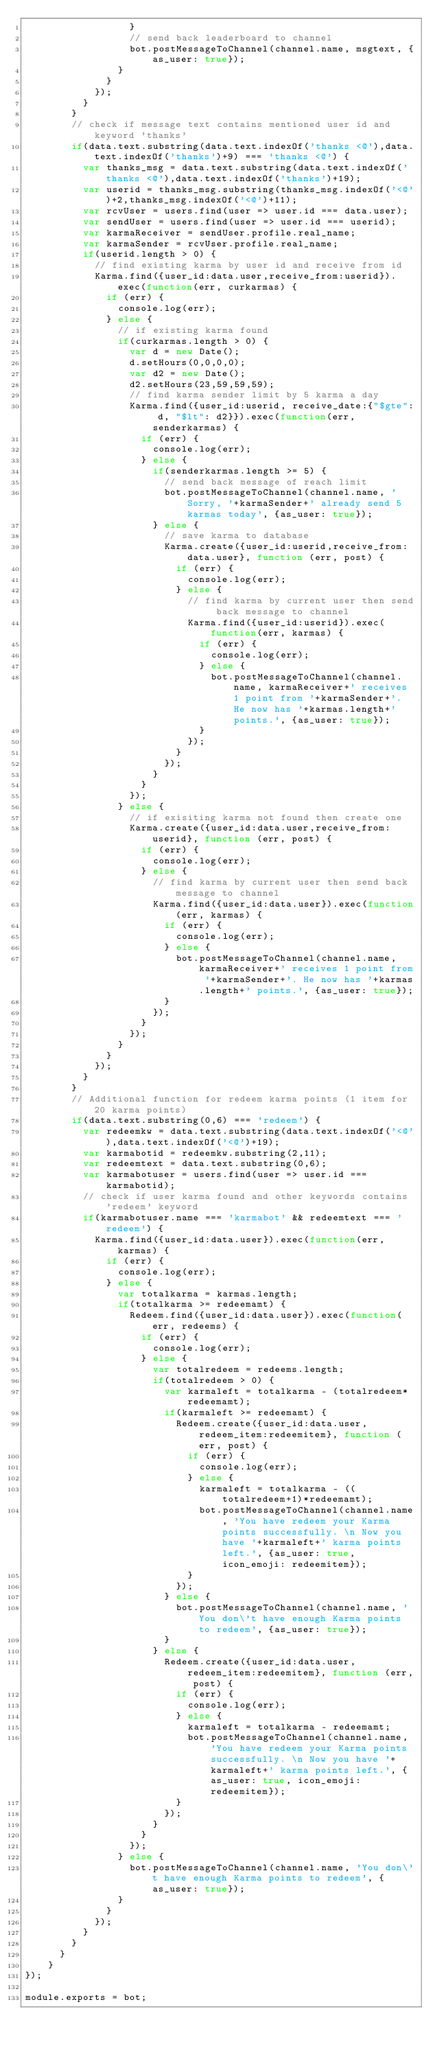Convert code to text. <code><loc_0><loc_0><loc_500><loc_500><_JavaScript_>                  }
                  // send back leaderboard to channel
                  bot.postMessageToChannel(channel.name, msgtext, {as_user: true});
                }
              }
            });
          }
        }
        // check if message text contains mentioned user id and keyword 'thanks'
        if(data.text.substring(data.text.indexOf('thanks <@'),data.text.indexOf('thanks')+9) === 'thanks <@') {
          var thanks_msg = data.text.substring(data.text.indexOf('thanks <@'),data.text.indexOf('thanks')+19);
          var userid = thanks_msg.substring(thanks_msg.indexOf('<@')+2,thanks_msg.indexOf('<@')+11);
          var rcvUser = users.find(user => user.id === data.user);
          var sendUser = users.find(user => user.id === userid);
          var karmaReceiver = sendUser.profile.real_name;
          var karmaSender = rcvUser.profile.real_name;
          if(userid.length > 0) {
            // find existing karma by user id and receive from id
            Karma.find({user_id:data.user,receive_from:userid}).exec(function(err, curkarmas) {
              if (err) {
                console.log(err);
              } else {
                // if existing karma found
                if(curkarmas.length > 0) {
                  var d = new Date();
                  d.setHours(0,0,0,0);
                  var d2 = new Date();
                  d2.setHours(23,59,59,59);
                  // find karma sender limit by 5 karma a day
                  Karma.find({user_id:userid, receive_date:{"$gte": d, "$lt": d2}}).exec(function(err, senderkarmas) {
                    if (err) {
                      console.log(err);
                    } else {
                      if(senderkarmas.length >= 5) {
                        // send back message of reach limit
                        bot.postMessageToChannel(channel.name, 'Sorry, '+karmaSender+' already send 5 karmas today', {as_user: true});
                      } else {
                        // save karma to database
                        Karma.create({user_id:userid,receive_from:data.user}, function (err, post) {
                          if (err) {
                            console.log(err);
                          } else {
                            // find karma by current user then send back message to channel
                            Karma.find({user_id:userid}).exec(function(err, karmas) {
                              if (err) {
                                console.log(err);
                              } else {
                                bot.postMessageToChannel(channel.name, karmaReceiver+' receives 1 point from '+karmaSender+'. He now has '+karmas.length+' points.', {as_user: true});
                              }
                            });
                          }
                        });
                      }
                    }
                  });
                } else {
                  // if exisiting karma not found then create one
                  Karma.create({user_id:data.user,receive_from:userid}, function (err, post) {
                    if (err) {
                      console.log(err);
                    } else {
                      // find karma by current user then send back message to channel
                      Karma.find({user_id:data.user}).exec(function(err, karmas) {
                        if (err) {
                          console.log(err);
                        } else {
                          bot.postMessageToChannel(channel.name, karmaReceiver+' receives 1 point from '+karmaSender+'. He now has '+karmas.length+' points.', {as_user: true});
                        }
                      });
                    }
                  });
                }
              }
            });
          }
        }
        // Additional function for redeem karma points (1 item for 20 karma points)
        if(data.text.substring(0,6) === 'redeem') {
          var redeemkw = data.text.substring(data.text.indexOf('<@'),data.text.indexOf('<@')+19);
          var karmabotid = redeemkw.substring(2,11);
          var redeemtext = data.text.substring(0,6);
          var karmabotuser = users.find(user => user.id === karmabotid);
          // check if user karma found and other keywords contains 'redeem' keyword
          if(karmabotuser.name === 'karmabot' && redeemtext === 'redeem') {
            Karma.find({user_id:data.user}).exec(function(err, karmas) {
              if (err) {
                console.log(err);
              } else {
                var totalkarma = karmas.length;
                if(totalkarma >= redeemamt) {
                  Redeem.find({user_id:data.user}).exec(function(err, redeems) {
                    if (err) {
                      console.log(err);
                    } else {
                      var totalredeem = redeems.length;
                      if(totalredeem > 0) {
                        var karmaleft = totalkarma - (totalredeem*redeemamt);
                        if(karmaleft >= redeemamt) {
                          Redeem.create({user_id:data.user,redeem_item:redeemitem}, function (err, post) {
                            if (err) {
                              console.log(err);
                            } else {
                              karmaleft = totalkarma - ((totalredeem+1)*redeemamt);
                              bot.postMessageToChannel(channel.name, 'You have redeem your Karma points successfully. \n Now you have '+karmaleft+' karma points left.', {as_user: true, icon_emoji: redeemitem});
                            }
                          });
                        } else {
                          bot.postMessageToChannel(channel.name, 'You don\'t have enough Karma points to redeem', {as_user: true});
                        }
                      } else {
                        Redeem.create({user_id:data.user,redeem_item:redeemitem}, function (err, post) {
                          if (err) {
                            console.log(err);
                          } else {
                            karmaleft = totalkarma - redeemamt;
                            bot.postMessageToChannel(channel.name, 'You have redeem your Karma points successfully. \n Now you have '+karmaleft+' karma points left.', {as_user: true, icon_emoji: redeemitem});
                          }
                        });
                      }
                    }
                  });
                } else {
                  bot.postMessageToChannel(channel.name, 'You don\'t have enough Karma points to redeem', {as_user: true});
                }
              }
            });
          }
        }
      }
    }
});

module.exports = bot;
</code> 